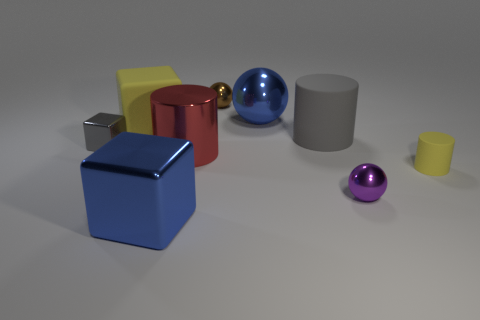Subtract all large cylinders. How many cylinders are left? 1 Subtract all gray cubes. How many cubes are left? 2 Subtract all cubes. How many objects are left? 6 Subtract all green cubes. How many gray cylinders are left? 1 Subtract all large blue shiny spheres. Subtract all large cyan metal blocks. How many objects are left? 8 Add 7 big blue metal objects. How many big blue metal objects are left? 9 Add 8 small blocks. How many small blocks exist? 9 Subtract 0 purple cubes. How many objects are left? 9 Subtract 2 balls. How many balls are left? 1 Subtract all yellow blocks. Subtract all yellow spheres. How many blocks are left? 2 